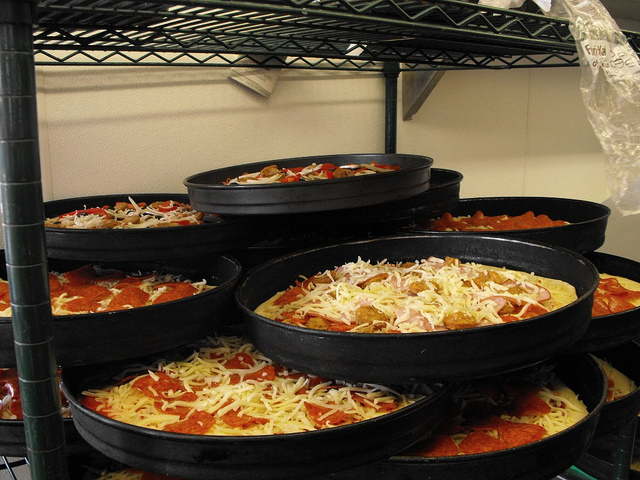Can you speculate the setting this photo was taken in, based on the visible details? The setting suggested by the image is likely a commercial kitchen or a pizzeria specifically designed for large-scale pizza production. The industrial shelving, high volumes of pizza pans, and half-prepared pizzas imply a busy environment that requires efficiency and the capacity to handle numerous orders simultaneously. 